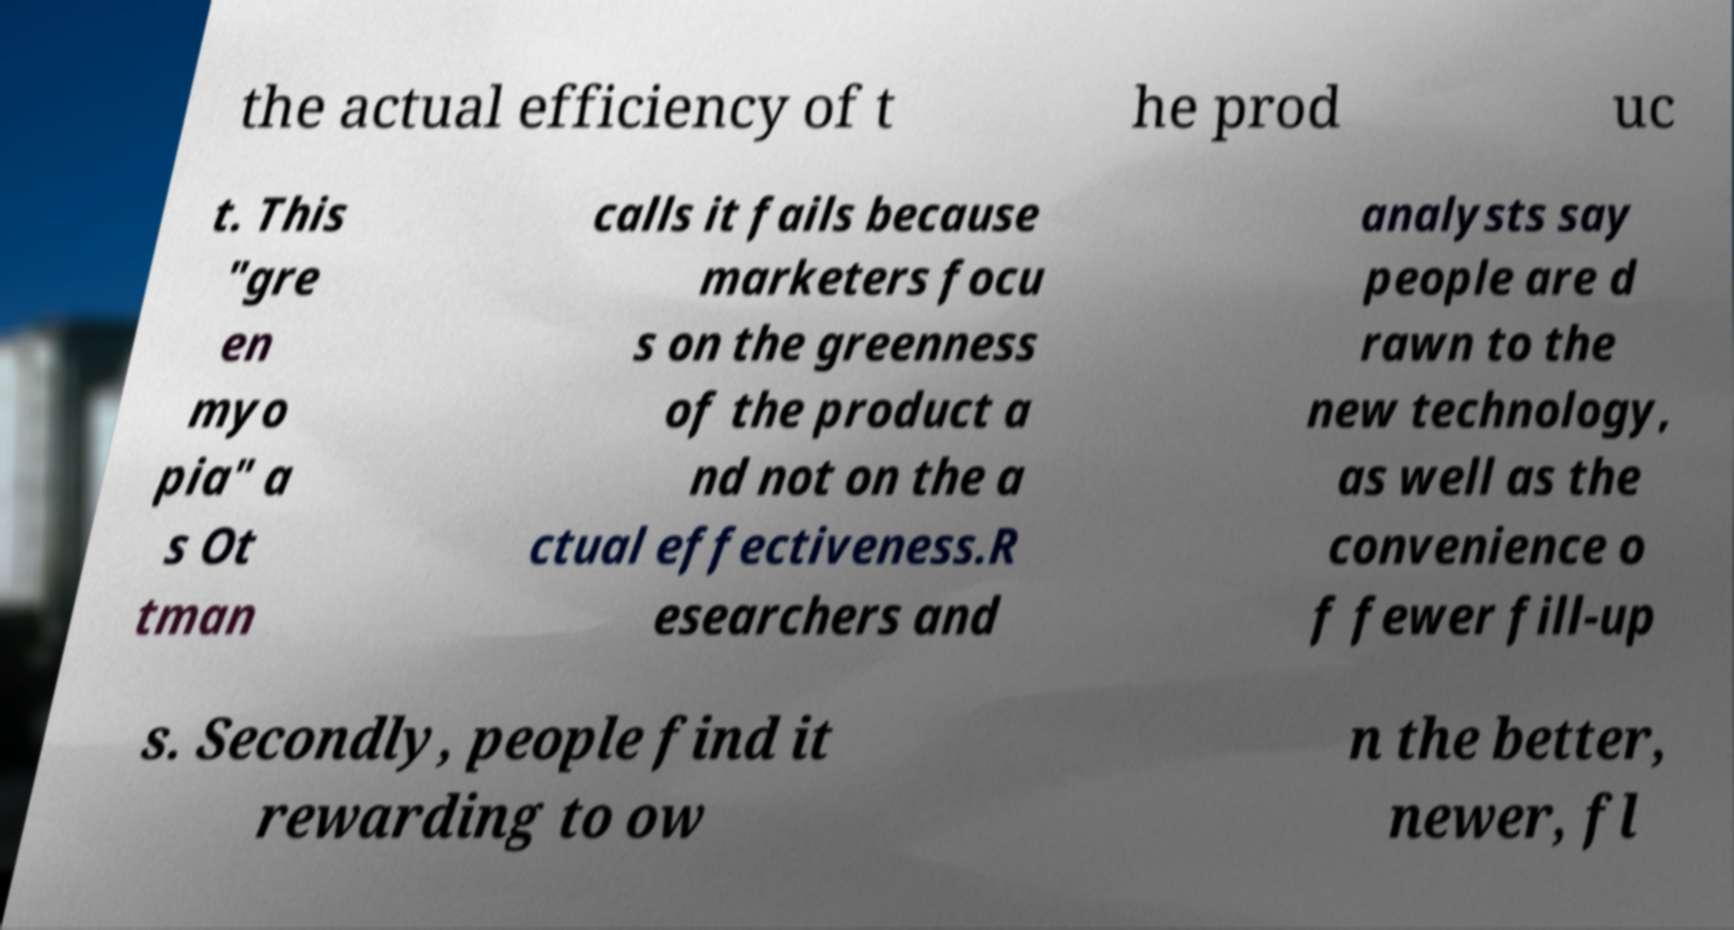Can you accurately transcribe the text from the provided image for me? the actual efficiency of t he prod uc t. This "gre en myo pia" a s Ot tman calls it fails because marketers focu s on the greenness of the product a nd not on the a ctual effectiveness.R esearchers and analysts say people are d rawn to the new technology, as well as the convenience o f fewer fill-up s. Secondly, people find it rewarding to ow n the better, newer, fl 